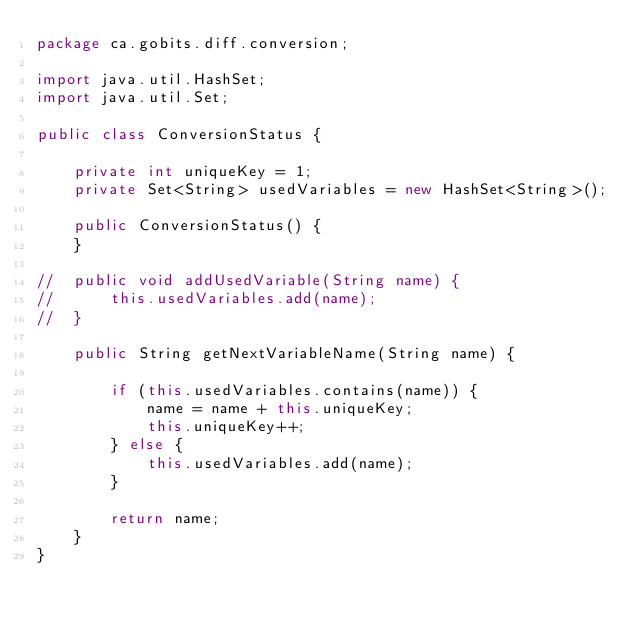<code> <loc_0><loc_0><loc_500><loc_500><_Java_>package ca.gobits.diff.conversion;

import java.util.HashSet;
import java.util.Set;

public class ConversionStatus {

	private int uniqueKey = 1;
	private Set<String> usedVariables = new HashSet<String>();
	
	public ConversionStatus() {		
	}

//	public void addUsedVariable(String name) {
//		this.usedVariables.add(name);
//	}

	public String getNextVariableName(String name) {
		
		if (this.usedVariables.contains(name)) {
			name = name + this.uniqueKey;
			this.uniqueKey++;
		} else {
			this.usedVariables.add(name);
		}
		
		return name;
	}
}
</code> 